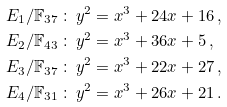Convert formula to latex. <formula><loc_0><loc_0><loc_500><loc_500>E _ { 1 } / \mathbb { F } _ { 3 7 } \, & \colon \, y ^ { 2 } = x ^ { 3 } + 2 4 x + 1 6 \, , \\ E _ { 2 } / \mathbb { F } _ { 4 3 } \, & \colon \, y ^ { 2 } = x ^ { 3 } + 3 6 x + 5 \, , \\ E _ { 3 } / \mathbb { F } _ { 3 7 } \, & \colon \, y ^ { 2 } = x ^ { 3 } + 2 2 x + 2 7 \, , \\ E _ { 4 } / \mathbb { F } _ { 3 1 } \, & \colon \, y ^ { 2 } = x ^ { 3 } + 2 6 x + 2 1 \, .</formula> 